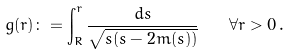Convert formula to latex. <formula><loc_0><loc_0><loc_500><loc_500>g ( r ) \colon = \int _ { R } ^ { r } \frac { d s } { \sqrt { s ( s - 2 m ( s ) ) } } \quad \forall r > 0 \, .</formula> 